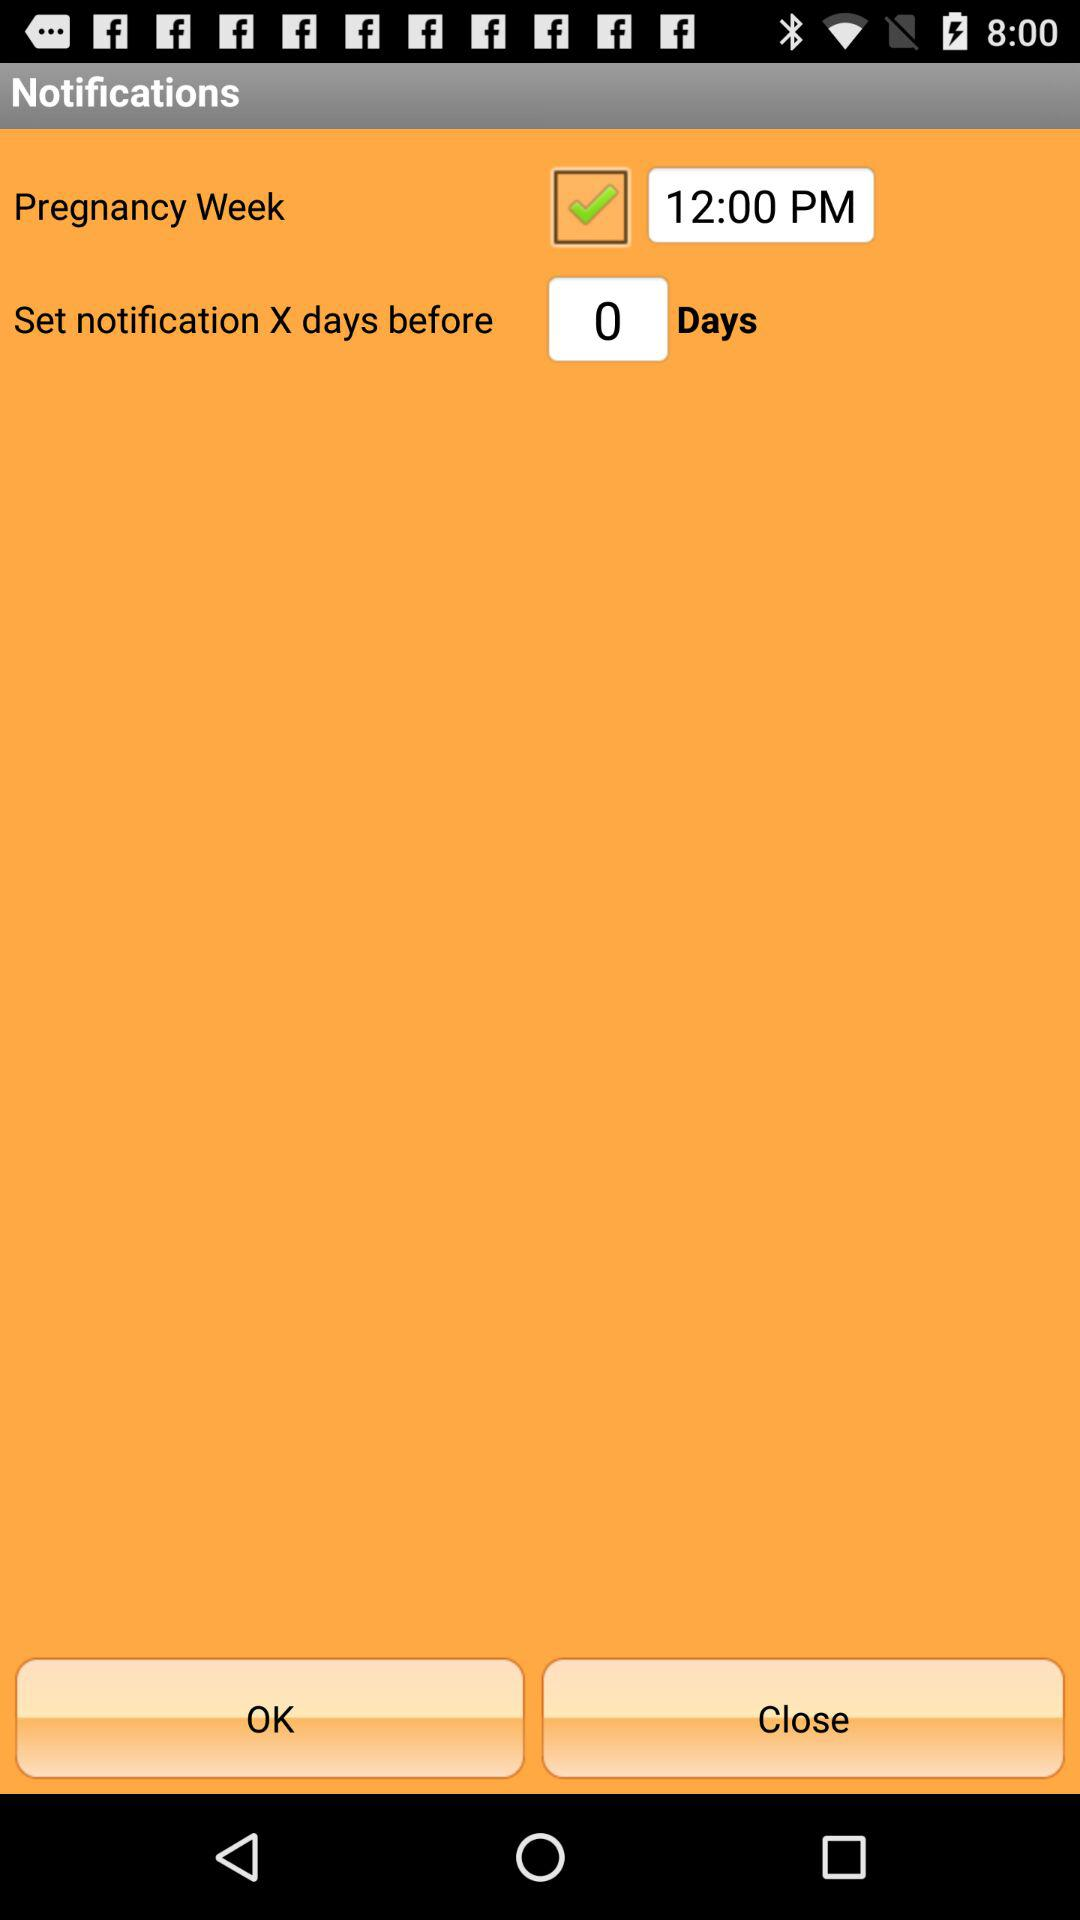What's the status of "Pregnancy Week" notification? The status of "Pregnancy Week" notification is "on". 